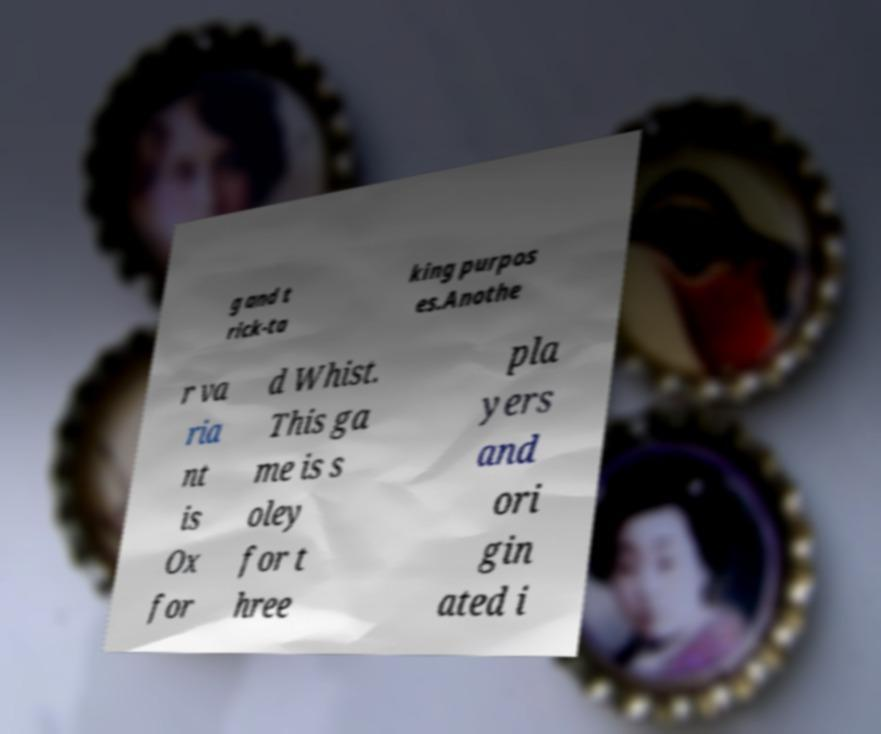Could you extract and type out the text from this image? g and t rick-ta king purpos es.Anothe r va ria nt is Ox for d Whist. This ga me is s oley for t hree pla yers and ori gin ated i 